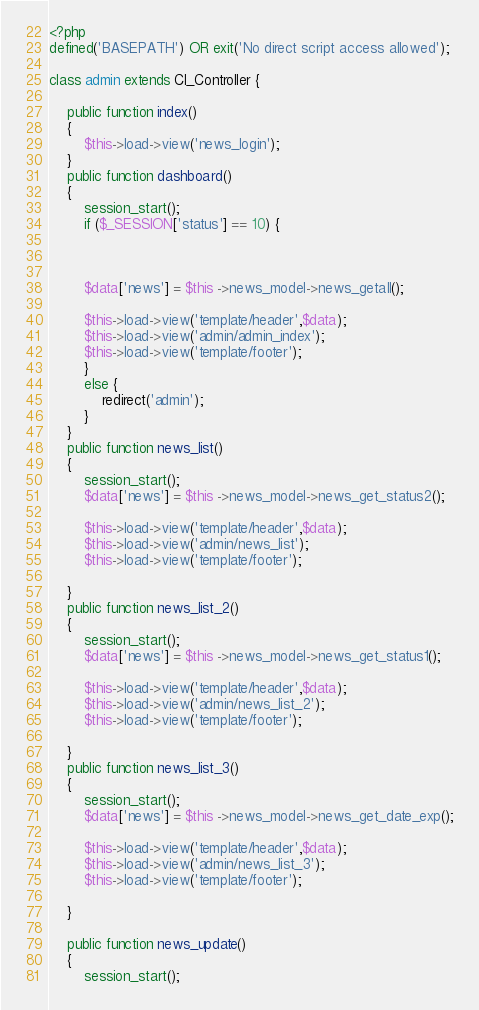<code> <loc_0><loc_0><loc_500><loc_500><_PHP_><?php
defined('BASEPATH') OR exit('No direct script access allowed');

class admin extends CI_Controller {

	public function index()
	{
		$this->load->view('news_login');
	}
	public function dashboard()
	{
		session_start();
		if ($_SESSION['status'] == 10) {



		$data['news'] = $this ->news_model->news_getall();

		$this->load->view('template/header',$data);
		$this->load->view('admin/admin_index');
		$this->load->view('template/footer');
		}
		else {
			redirect('admin');
		}
	}
	public function news_list()
	{
		session_start();
		$data['news'] = $this ->news_model->news_get_status2();

		$this->load->view('template/header',$data);
		$this->load->view('admin/news_list');
		$this->load->view('template/footer');

	}
	public function news_list_2()
	{
		session_start();
		$data['news'] = $this ->news_model->news_get_status1();

		$this->load->view('template/header',$data);
		$this->load->view('admin/news_list_2');
		$this->load->view('template/footer');

	}
	public function news_list_3()
	{
		session_start();
		$data['news'] = $this ->news_model->news_get_date_exp();

		$this->load->view('template/header',$data);
		$this->load->view('admin/news_list_3');
		$this->load->view('template/footer');

	}

	public function news_update()
	{
		session_start();</code> 